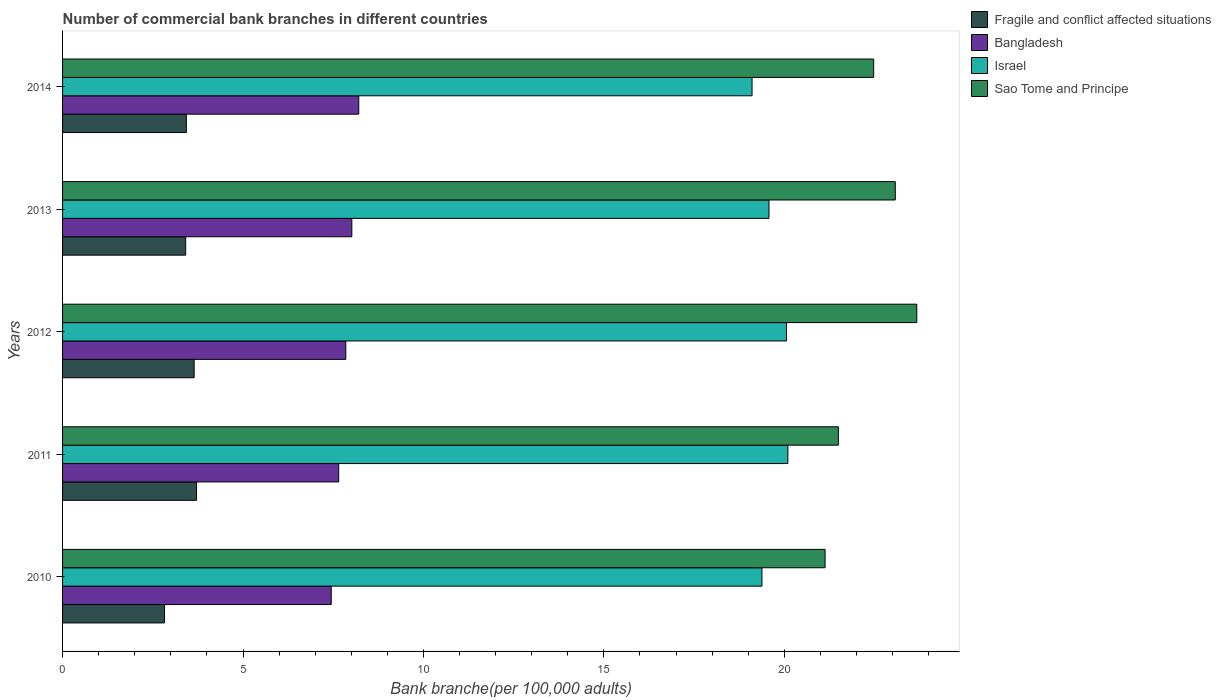How many different coloured bars are there?
Your answer should be very brief. 4. Are the number of bars per tick equal to the number of legend labels?
Make the answer very short. Yes. How many bars are there on the 3rd tick from the top?
Keep it short and to the point. 4. How many bars are there on the 2nd tick from the bottom?
Provide a short and direct response. 4. In how many cases, is the number of bars for a given year not equal to the number of legend labels?
Make the answer very short. 0. What is the number of commercial bank branches in Sao Tome and Principe in 2014?
Give a very brief answer. 22.48. Across all years, what is the maximum number of commercial bank branches in Bangladesh?
Ensure brevity in your answer.  8.21. Across all years, what is the minimum number of commercial bank branches in Fragile and conflict affected situations?
Provide a succinct answer. 2.83. In which year was the number of commercial bank branches in Israel maximum?
Ensure brevity in your answer.  2011. In which year was the number of commercial bank branches in Israel minimum?
Offer a very short reply. 2014. What is the total number of commercial bank branches in Fragile and conflict affected situations in the graph?
Give a very brief answer. 17.03. What is the difference between the number of commercial bank branches in Bangladesh in 2010 and that in 2011?
Your answer should be compact. -0.21. What is the difference between the number of commercial bank branches in Israel in 2011 and the number of commercial bank branches in Bangladesh in 2013?
Provide a short and direct response. 12.08. What is the average number of commercial bank branches in Israel per year?
Your answer should be compact. 19.64. In the year 2013, what is the difference between the number of commercial bank branches in Fragile and conflict affected situations and number of commercial bank branches in Bangladesh?
Give a very brief answer. -4.6. In how many years, is the number of commercial bank branches in Bangladesh greater than 14 ?
Give a very brief answer. 0. What is the ratio of the number of commercial bank branches in Israel in 2011 to that in 2013?
Ensure brevity in your answer.  1.03. Is the number of commercial bank branches in Israel in 2013 less than that in 2014?
Make the answer very short. No. Is the difference between the number of commercial bank branches in Fragile and conflict affected situations in 2010 and 2013 greater than the difference between the number of commercial bank branches in Bangladesh in 2010 and 2013?
Give a very brief answer. No. What is the difference between the highest and the second highest number of commercial bank branches in Israel?
Provide a short and direct response. 0.04. What is the difference between the highest and the lowest number of commercial bank branches in Sao Tome and Principe?
Provide a short and direct response. 2.54. In how many years, is the number of commercial bank branches in Bangladesh greater than the average number of commercial bank branches in Bangladesh taken over all years?
Offer a terse response. 3. What does the 2nd bar from the top in 2013 represents?
Offer a very short reply. Israel. What does the 4th bar from the bottom in 2012 represents?
Your response must be concise. Sao Tome and Principe. Are the values on the major ticks of X-axis written in scientific E-notation?
Ensure brevity in your answer.  No. Where does the legend appear in the graph?
Give a very brief answer. Top right. How many legend labels are there?
Your answer should be very brief. 4. How are the legend labels stacked?
Keep it short and to the point. Vertical. What is the title of the graph?
Keep it short and to the point. Number of commercial bank branches in different countries. What is the label or title of the X-axis?
Ensure brevity in your answer.  Bank branche(per 100,0 adults). What is the Bank branche(per 100,000 adults) in Fragile and conflict affected situations in 2010?
Keep it short and to the point. 2.83. What is the Bank branche(per 100,000 adults) in Bangladesh in 2010?
Keep it short and to the point. 7.44. What is the Bank branche(per 100,000 adults) in Israel in 2010?
Ensure brevity in your answer.  19.38. What is the Bank branche(per 100,000 adults) of Sao Tome and Principe in 2010?
Your answer should be compact. 21.13. What is the Bank branche(per 100,000 adults) in Fragile and conflict affected situations in 2011?
Your response must be concise. 3.71. What is the Bank branche(per 100,000 adults) of Bangladesh in 2011?
Make the answer very short. 7.65. What is the Bank branche(per 100,000 adults) of Israel in 2011?
Keep it short and to the point. 20.1. What is the Bank branche(per 100,000 adults) in Sao Tome and Principe in 2011?
Make the answer very short. 21.5. What is the Bank branche(per 100,000 adults) in Fragile and conflict affected situations in 2012?
Provide a succinct answer. 3.65. What is the Bank branche(per 100,000 adults) in Bangladesh in 2012?
Your response must be concise. 7.85. What is the Bank branche(per 100,000 adults) of Israel in 2012?
Provide a succinct answer. 20.06. What is the Bank branche(per 100,000 adults) of Sao Tome and Principe in 2012?
Give a very brief answer. 23.67. What is the Bank branche(per 100,000 adults) of Fragile and conflict affected situations in 2013?
Offer a terse response. 3.41. What is the Bank branche(per 100,000 adults) in Bangladesh in 2013?
Your response must be concise. 8.02. What is the Bank branche(per 100,000 adults) of Israel in 2013?
Provide a succinct answer. 19.57. What is the Bank branche(per 100,000 adults) in Sao Tome and Principe in 2013?
Offer a terse response. 23.07. What is the Bank branche(per 100,000 adults) in Fragile and conflict affected situations in 2014?
Make the answer very short. 3.43. What is the Bank branche(per 100,000 adults) in Bangladesh in 2014?
Ensure brevity in your answer.  8.21. What is the Bank branche(per 100,000 adults) of Israel in 2014?
Offer a terse response. 19.11. What is the Bank branche(per 100,000 adults) in Sao Tome and Principe in 2014?
Your response must be concise. 22.48. Across all years, what is the maximum Bank branche(per 100,000 adults) of Fragile and conflict affected situations?
Keep it short and to the point. 3.71. Across all years, what is the maximum Bank branche(per 100,000 adults) in Bangladesh?
Ensure brevity in your answer.  8.21. Across all years, what is the maximum Bank branche(per 100,000 adults) of Israel?
Your answer should be compact. 20.1. Across all years, what is the maximum Bank branche(per 100,000 adults) in Sao Tome and Principe?
Your answer should be very brief. 23.67. Across all years, what is the minimum Bank branche(per 100,000 adults) in Fragile and conflict affected situations?
Provide a succinct answer. 2.83. Across all years, what is the minimum Bank branche(per 100,000 adults) of Bangladesh?
Your answer should be compact. 7.44. Across all years, what is the minimum Bank branche(per 100,000 adults) of Israel?
Your response must be concise. 19.11. Across all years, what is the minimum Bank branche(per 100,000 adults) of Sao Tome and Principe?
Your answer should be very brief. 21.13. What is the total Bank branche(per 100,000 adults) of Fragile and conflict affected situations in the graph?
Your answer should be very brief. 17.03. What is the total Bank branche(per 100,000 adults) in Bangladesh in the graph?
Provide a short and direct response. 39.17. What is the total Bank branche(per 100,000 adults) in Israel in the graph?
Give a very brief answer. 98.22. What is the total Bank branche(per 100,000 adults) in Sao Tome and Principe in the graph?
Your answer should be compact. 111.84. What is the difference between the Bank branche(per 100,000 adults) of Fragile and conflict affected situations in 2010 and that in 2011?
Provide a succinct answer. -0.89. What is the difference between the Bank branche(per 100,000 adults) in Bangladesh in 2010 and that in 2011?
Make the answer very short. -0.21. What is the difference between the Bank branche(per 100,000 adults) in Israel in 2010 and that in 2011?
Offer a terse response. -0.72. What is the difference between the Bank branche(per 100,000 adults) in Sao Tome and Principe in 2010 and that in 2011?
Your answer should be very brief. -0.37. What is the difference between the Bank branche(per 100,000 adults) of Fragile and conflict affected situations in 2010 and that in 2012?
Ensure brevity in your answer.  -0.82. What is the difference between the Bank branche(per 100,000 adults) in Bangladesh in 2010 and that in 2012?
Provide a short and direct response. -0.4. What is the difference between the Bank branche(per 100,000 adults) of Israel in 2010 and that in 2012?
Your answer should be compact. -0.68. What is the difference between the Bank branche(per 100,000 adults) of Sao Tome and Principe in 2010 and that in 2012?
Your answer should be compact. -2.54. What is the difference between the Bank branche(per 100,000 adults) in Fragile and conflict affected situations in 2010 and that in 2013?
Your response must be concise. -0.59. What is the difference between the Bank branche(per 100,000 adults) of Bangladesh in 2010 and that in 2013?
Provide a succinct answer. -0.57. What is the difference between the Bank branche(per 100,000 adults) of Israel in 2010 and that in 2013?
Provide a short and direct response. -0.19. What is the difference between the Bank branche(per 100,000 adults) in Sao Tome and Principe in 2010 and that in 2013?
Offer a terse response. -1.94. What is the difference between the Bank branche(per 100,000 adults) of Fragile and conflict affected situations in 2010 and that in 2014?
Keep it short and to the point. -0.61. What is the difference between the Bank branche(per 100,000 adults) of Bangladesh in 2010 and that in 2014?
Offer a terse response. -0.76. What is the difference between the Bank branche(per 100,000 adults) of Israel in 2010 and that in 2014?
Your answer should be very brief. 0.27. What is the difference between the Bank branche(per 100,000 adults) of Sao Tome and Principe in 2010 and that in 2014?
Your answer should be very brief. -1.35. What is the difference between the Bank branche(per 100,000 adults) of Fragile and conflict affected situations in 2011 and that in 2012?
Offer a very short reply. 0.07. What is the difference between the Bank branche(per 100,000 adults) in Bangladesh in 2011 and that in 2012?
Ensure brevity in your answer.  -0.2. What is the difference between the Bank branche(per 100,000 adults) in Israel in 2011 and that in 2012?
Offer a terse response. 0.04. What is the difference between the Bank branche(per 100,000 adults) of Sao Tome and Principe in 2011 and that in 2012?
Ensure brevity in your answer.  -2.17. What is the difference between the Bank branche(per 100,000 adults) of Fragile and conflict affected situations in 2011 and that in 2013?
Give a very brief answer. 0.3. What is the difference between the Bank branche(per 100,000 adults) of Bangladesh in 2011 and that in 2013?
Your answer should be very brief. -0.36. What is the difference between the Bank branche(per 100,000 adults) of Israel in 2011 and that in 2013?
Offer a very short reply. 0.52. What is the difference between the Bank branche(per 100,000 adults) of Sao Tome and Principe in 2011 and that in 2013?
Your answer should be very brief. -1.58. What is the difference between the Bank branche(per 100,000 adults) in Fragile and conflict affected situations in 2011 and that in 2014?
Make the answer very short. 0.28. What is the difference between the Bank branche(per 100,000 adults) in Bangladesh in 2011 and that in 2014?
Give a very brief answer. -0.56. What is the difference between the Bank branche(per 100,000 adults) of Israel in 2011 and that in 2014?
Ensure brevity in your answer.  0.99. What is the difference between the Bank branche(per 100,000 adults) in Sao Tome and Principe in 2011 and that in 2014?
Offer a very short reply. -0.98. What is the difference between the Bank branche(per 100,000 adults) in Fragile and conflict affected situations in 2012 and that in 2013?
Make the answer very short. 0.23. What is the difference between the Bank branche(per 100,000 adults) of Bangladesh in 2012 and that in 2013?
Provide a succinct answer. -0.17. What is the difference between the Bank branche(per 100,000 adults) in Israel in 2012 and that in 2013?
Provide a succinct answer. 0.49. What is the difference between the Bank branche(per 100,000 adults) of Sao Tome and Principe in 2012 and that in 2013?
Your response must be concise. 0.6. What is the difference between the Bank branche(per 100,000 adults) of Fragile and conflict affected situations in 2012 and that in 2014?
Your answer should be very brief. 0.22. What is the difference between the Bank branche(per 100,000 adults) in Bangladesh in 2012 and that in 2014?
Offer a terse response. -0.36. What is the difference between the Bank branche(per 100,000 adults) of Israel in 2012 and that in 2014?
Ensure brevity in your answer.  0.95. What is the difference between the Bank branche(per 100,000 adults) of Sao Tome and Principe in 2012 and that in 2014?
Ensure brevity in your answer.  1.2. What is the difference between the Bank branche(per 100,000 adults) in Fragile and conflict affected situations in 2013 and that in 2014?
Keep it short and to the point. -0.02. What is the difference between the Bank branche(per 100,000 adults) of Bangladesh in 2013 and that in 2014?
Your answer should be compact. -0.19. What is the difference between the Bank branche(per 100,000 adults) of Israel in 2013 and that in 2014?
Offer a very short reply. 0.47. What is the difference between the Bank branche(per 100,000 adults) of Sao Tome and Principe in 2013 and that in 2014?
Make the answer very short. 0.6. What is the difference between the Bank branche(per 100,000 adults) of Fragile and conflict affected situations in 2010 and the Bank branche(per 100,000 adults) of Bangladesh in 2011?
Keep it short and to the point. -4.83. What is the difference between the Bank branche(per 100,000 adults) of Fragile and conflict affected situations in 2010 and the Bank branche(per 100,000 adults) of Israel in 2011?
Keep it short and to the point. -17.27. What is the difference between the Bank branche(per 100,000 adults) in Fragile and conflict affected situations in 2010 and the Bank branche(per 100,000 adults) in Sao Tome and Principe in 2011?
Provide a short and direct response. -18.67. What is the difference between the Bank branche(per 100,000 adults) of Bangladesh in 2010 and the Bank branche(per 100,000 adults) of Israel in 2011?
Ensure brevity in your answer.  -12.65. What is the difference between the Bank branche(per 100,000 adults) of Bangladesh in 2010 and the Bank branche(per 100,000 adults) of Sao Tome and Principe in 2011?
Make the answer very short. -14.05. What is the difference between the Bank branche(per 100,000 adults) in Israel in 2010 and the Bank branche(per 100,000 adults) in Sao Tome and Principe in 2011?
Provide a succinct answer. -2.12. What is the difference between the Bank branche(per 100,000 adults) in Fragile and conflict affected situations in 2010 and the Bank branche(per 100,000 adults) in Bangladesh in 2012?
Keep it short and to the point. -5.02. What is the difference between the Bank branche(per 100,000 adults) in Fragile and conflict affected situations in 2010 and the Bank branche(per 100,000 adults) in Israel in 2012?
Offer a terse response. -17.23. What is the difference between the Bank branche(per 100,000 adults) in Fragile and conflict affected situations in 2010 and the Bank branche(per 100,000 adults) in Sao Tome and Principe in 2012?
Your answer should be compact. -20.84. What is the difference between the Bank branche(per 100,000 adults) of Bangladesh in 2010 and the Bank branche(per 100,000 adults) of Israel in 2012?
Your answer should be compact. -12.62. What is the difference between the Bank branche(per 100,000 adults) of Bangladesh in 2010 and the Bank branche(per 100,000 adults) of Sao Tome and Principe in 2012?
Offer a terse response. -16.23. What is the difference between the Bank branche(per 100,000 adults) of Israel in 2010 and the Bank branche(per 100,000 adults) of Sao Tome and Principe in 2012?
Provide a short and direct response. -4.29. What is the difference between the Bank branche(per 100,000 adults) in Fragile and conflict affected situations in 2010 and the Bank branche(per 100,000 adults) in Bangladesh in 2013?
Offer a very short reply. -5.19. What is the difference between the Bank branche(per 100,000 adults) of Fragile and conflict affected situations in 2010 and the Bank branche(per 100,000 adults) of Israel in 2013?
Your answer should be very brief. -16.75. What is the difference between the Bank branche(per 100,000 adults) in Fragile and conflict affected situations in 2010 and the Bank branche(per 100,000 adults) in Sao Tome and Principe in 2013?
Offer a very short reply. -20.25. What is the difference between the Bank branche(per 100,000 adults) in Bangladesh in 2010 and the Bank branche(per 100,000 adults) in Israel in 2013?
Provide a short and direct response. -12.13. What is the difference between the Bank branche(per 100,000 adults) of Bangladesh in 2010 and the Bank branche(per 100,000 adults) of Sao Tome and Principe in 2013?
Give a very brief answer. -15.63. What is the difference between the Bank branche(per 100,000 adults) of Israel in 2010 and the Bank branche(per 100,000 adults) of Sao Tome and Principe in 2013?
Provide a short and direct response. -3.69. What is the difference between the Bank branche(per 100,000 adults) in Fragile and conflict affected situations in 2010 and the Bank branche(per 100,000 adults) in Bangladesh in 2014?
Make the answer very short. -5.38. What is the difference between the Bank branche(per 100,000 adults) of Fragile and conflict affected situations in 2010 and the Bank branche(per 100,000 adults) of Israel in 2014?
Offer a very short reply. -16.28. What is the difference between the Bank branche(per 100,000 adults) of Fragile and conflict affected situations in 2010 and the Bank branche(per 100,000 adults) of Sao Tome and Principe in 2014?
Offer a very short reply. -19.65. What is the difference between the Bank branche(per 100,000 adults) in Bangladesh in 2010 and the Bank branche(per 100,000 adults) in Israel in 2014?
Your response must be concise. -11.66. What is the difference between the Bank branche(per 100,000 adults) of Bangladesh in 2010 and the Bank branche(per 100,000 adults) of Sao Tome and Principe in 2014?
Your response must be concise. -15.03. What is the difference between the Bank branche(per 100,000 adults) in Israel in 2010 and the Bank branche(per 100,000 adults) in Sao Tome and Principe in 2014?
Give a very brief answer. -3.1. What is the difference between the Bank branche(per 100,000 adults) of Fragile and conflict affected situations in 2011 and the Bank branche(per 100,000 adults) of Bangladesh in 2012?
Your response must be concise. -4.14. What is the difference between the Bank branche(per 100,000 adults) of Fragile and conflict affected situations in 2011 and the Bank branche(per 100,000 adults) of Israel in 2012?
Ensure brevity in your answer.  -16.35. What is the difference between the Bank branche(per 100,000 adults) in Fragile and conflict affected situations in 2011 and the Bank branche(per 100,000 adults) in Sao Tome and Principe in 2012?
Make the answer very short. -19.96. What is the difference between the Bank branche(per 100,000 adults) of Bangladesh in 2011 and the Bank branche(per 100,000 adults) of Israel in 2012?
Ensure brevity in your answer.  -12.41. What is the difference between the Bank branche(per 100,000 adults) of Bangladesh in 2011 and the Bank branche(per 100,000 adults) of Sao Tome and Principe in 2012?
Provide a short and direct response. -16.02. What is the difference between the Bank branche(per 100,000 adults) in Israel in 2011 and the Bank branche(per 100,000 adults) in Sao Tome and Principe in 2012?
Your answer should be compact. -3.57. What is the difference between the Bank branche(per 100,000 adults) in Fragile and conflict affected situations in 2011 and the Bank branche(per 100,000 adults) in Bangladesh in 2013?
Your answer should be very brief. -4.3. What is the difference between the Bank branche(per 100,000 adults) in Fragile and conflict affected situations in 2011 and the Bank branche(per 100,000 adults) in Israel in 2013?
Give a very brief answer. -15.86. What is the difference between the Bank branche(per 100,000 adults) in Fragile and conflict affected situations in 2011 and the Bank branche(per 100,000 adults) in Sao Tome and Principe in 2013?
Your answer should be very brief. -19.36. What is the difference between the Bank branche(per 100,000 adults) in Bangladesh in 2011 and the Bank branche(per 100,000 adults) in Israel in 2013?
Give a very brief answer. -11.92. What is the difference between the Bank branche(per 100,000 adults) of Bangladesh in 2011 and the Bank branche(per 100,000 adults) of Sao Tome and Principe in 2013?
Ensure brevity in your answer.  -15.42. What is the difference between the Bank branche(per 100,000 adults) in Israel in 2011 and the Bank branche(per 100,000 adults) in Sao Tome and Principe in 2013?
Provide a succinct answer. -2.98. What is the difference between the Bank branche(per 100,000 adults) of Fragile and conflict affected situations in 2011 and the Bank branche(per 100,000 adults) of Bangladesh in 2014?
Give a very brief answer. -4.49. What is the difference between the Bank branche(per 100,000 adults) in Fragile and conflict affected situations in 2011 and the Bank branche(per 100,000 adults) in Israel in 2014?
Your answer should be compact. -15.39. What is the difference between the Bank branche(per 100,000 adults) of Fragile and conflict affected situations in 2011 and the Bank branche(per 100,000 adults) of Sao Tome and Principe in 2014?
Provide a succinct answer. -18.76. What is the difference between the Bank branche(per 100,000 adults) in Bangladesh in 2011 and the Bank branche(per 100,000 adults) in Israel in 2014?
Your response must be concise. -11.45. What is the difference between the Bank branche(per 100,000 adults) of Bangladesh in 2011 and the Bank branche(per 100,000 adults) of Sao Tome and Principe in 2014?
Your response must be concise. -14.82. What is the difference between the Bank branche(per 100,000 adults) of Israel in 2011 and the Bank branche(per 100,000 adults) of Sao Tome and Principe in 2014?
Make the answer very short. -2.38. What is the difference between the Bank branche(per 100,000 adults) of Fragile and conflict affected situations in 2012 and the Bank branche(per 100,000 adults) of Bangladesh in 2013?
Ensure brevity in your answer.  -4.37. What is the difference between the Bank branche(per 100,000 adults) of Fragile and conflict affected situations in 2012 and the Bank branche(per 100,000 adults) of Israel in 2013?
Provide a succinct answer. -15.93. What is the difference between the Bank branche(per 100,000 adults) of Fragile and conflict affected situations in 2012 and the Bank branche(per 100,000 adults) of Sao Tome and Principe in 2013?
Give a very brief answer. -19.43. What is the difference between the Bank branche(per 100,000 adults) of Bangladesh in 2012 and the Bank branche(per 100,000 adults) of Israel in 2013?
Your answer should be very brief. -11.73. What is the difference between the Bank branche(per 100,000 adults) in Bangladesh in 2012 and the Bank branche(per 100,000 adults) in Sao Tome and Principe in 2013?
Provide a succinct answer. -15.23. What is the difference between the Bank branche(per 100,000 adults) in Israel in 2012 and the Bank branche(per 100,000 adults) in Sao Tome and Principe in 2013?
Provide a short and direct response. -3.01. What is the difference between the Bank branche(per 100,000 adults) in Fragile and conflict affected situations in 2012 and the Bank branche(per 100,000 adults) in Bangladesh in 2014?
Provide a succinct answer. -4.56. What is the difference between the Bank branche(per 100,000 adults) of Fragile and conflict affected situations in 2012 and the Bank branche(per 100,000 adults) of Israel in 2014?
Ensure brevity in your answer.  -15.46. What is the difference between the Bank branche(per 100,000 adults) of Fragile and conflict affected situations in 2012 and the Bank branche(per 100,000 adults) of Sao Tome and Principe in 2014?
Provide a short and direct response. -18.83. What is the difference between the Bank branche(per 100,000 adults) in Bangladesh in 2012 and the Bank branche(per 100,000 adults) in Israel in 2014?
Your response must be concise. -11.26. What is the difference between the Bank branche(per 100,000 adults) of Bangladesh in 2012 and the Bank branche(per 100,000 adults) of Sao Tome and Principe in 2014?
Your answer should be very brief. -14.63. What is the difference between the Bank branche(per 100,000 adults) of Israel in 2012 and the Bank branche(per 100,000 adults) of Sao Tome and Principe in 2014?
Provide a short and direct response. -2.42. What is the difference between the Bank branche(per 100,000 adults) in Fragile and conflict affected situations in 2013 and the Bank branche(per 100,000 adults) in Bangladesh in 2014?
Provide a succinct answer. -4.8. What is the difference between the Bank branche(per 100,000 adults) of Fragile and conflict affected situations in 2013 and the Bank branche(per 100,000 adults) of Israel in 2014?
Keep it short and to the point. -15.69. What is the difference between the Bank branche(per 100,000 adults) in Fragile and conflict affected situations in 2013 and the Bank branche(per 100,000 adults) in Sao Tome and Principe in 2014?
Ensure brevity in your answer.  -19.06. What is the difference between the Bank branche(per 100,000 adults) in Bangladesh in 2013 and the Bank branche(per 100,000 adults) in Israel in 2014?
Offer a terse response. -11.09. What is the difference between the Bank branche(per 100,000 adults) of Bangladesh in 2013 and the Bank branche(per 100,000 adults) of Sao Tome and Principe in 2014?
Your answer should be very brief. -14.46. What is the difference between the Bank branche(per 100,000 adults) in Israel in 2013 and the Bank branche(per 100,000 adults) in Sao Tome and Principe in 2014?
Your response must be concise. -2.9. What is the average Bank branche(per 100,000 adults) of Fragile and conflict affected situations per year?
Your response must be concise. 3.41. What is the average Bank branche(per 100,000 adults) of Bangladesh per year?
Make the answer very short. 7.83. What is the average Bank branche(per 100,000 adults) of Israel per year?
Offer a terse response. 19.64. What is the average Bank branche(per 100,000 adults) in Sao Tome and Principe per year?
Your response must be concise. 22.37. In the year 2010, what is the difference between the Bank branche(per 100,000 adults) in Fragile and conflict affected situations and Bank branche(per 100,000 adults) in Bangladesh?
Your answer should be compact. -4.62. In the year 2010, what is the difference between the Bank branche(per 100,000 adults) in Fragile and conflict affected situations and Bank branche(per 100,000 adults) in Israel?
Keep it short and to the point. -16.55. In the year 2010, what is the difference between the Bank branche(per 100,000 adults) of Fragile and conflict affected situations and Bank branche(per 100,000 adults) of Sao Tome and Principe?
Offer a very short reply. -18.3. In the year 2010, what is the difference between the Bank branche(per 100,000 adults) of Bangladesh and Bank branche(per 100,000 adults) of Israel?
Offer a very short reply. -11.94. In the year 2010, what is the difference between the Bank branche(per 100,000 adults) in Bangladesh and Bank branche(per 100,000 adults) in Sao Tome and Principe?
Give a very brief answer. -13.68. In the year 2010, what is the difference between the Bank branche(per 100,000 adults) of Israel and Bank branche(per 100,000 adults) of Sao Tome and Principe?
Give a very brief answer. -1.75. In the year 2011, what is the difference between the Bank branche(per 100,000 adults) of Fragile and conflict affected situations and Bank branche(per 100,000 adults) of Bangladesh?
Offer a terse response. -3.94. In the year 2011, what is the difference between the Bank branche(per 100,000 adults) of Fragile and conflict affected situations and Bank branche(per 100,000 adults) of Israel?
Give a very brief answer. -16.38. In the year 2011, what is the difference between the Bank branche(per 100,000 adults) of Fragile and conflict affected situations and Bank branche(per 100,000 adults) of Sao Tome and Principe?
Keep it short and to the point. -17.78. In the year 2011, what is the difference between the Bank branche(per 100,000 adults) in Bangladesh and Bank branche(per 100,000 adults) in Israel?
Provide a short and direct response. -12.45. In the year 2011, what is the difference between the Bank branche(per 100,000 adults) in Bangladesh and Bank branche(per 100,000 adults) in Sao Tome and Principe?
Your answer should be very brief. -13.85. In the year 2011, what is the difference between the Bank branche(per 100,000 adults) in Israel and Bank branche(per 100,000 adults) in Sao Tome and Principe?
Offer a very short reply. -1.4. In the year 2012, what is the difference between the Bank branche(per 100,000 adults) in Fragile and conflict affected situations and Bank branche(per 100,000 adults) in Bangladesh?
Ensure brevity in your answer.  -4.2. In the year 2012, what is the difference between the Bank branche(per 100,000 adults) of Fragile and conflict affected situations and Bank branche(per 100,000 adults) of Israel?
Make the answer very short. -16.41. In the year 2012, what is the difference between the Bank branche(per 100,000 adults) in Fragile and conflict affected situations and Bank branche(per 100,000 adults) in Sao Tome and Principe?
Make the answer very short. -20.02. In the year 2012, what is the difference between the Bank branche(per 100,000 adults) of Bangladesh and Bank branche(per 100,000 adults) of Israel?
Provide a succinct answer. -12.21. In the year 2012, what is the difference between the Bank branche(per 100,000 adults) in Bangladesh and Bank branche(per 100,000 adults) in Sao Tome and Principe?
Provide a short and direct response. -15.82. In the year 2012, what is the difference between the Bank branche(per 100,000 adults) in Israel and Bank branche(per 100,000 adults) in Sao Tome and Principe?
Give a very brief answer. -3.61. In the year 2013, what is the difference between the Bank branche(per 100,000 adults) in Fragile and conflict affected situations and Bank branche(per 100,000 adults) in Bangladesh?
Make the answer very short. -4.6. In the year 2013, what is the difference between the Bank branche(per 100,000 adults) in Fragile and conflict affected situations and Bank branche(per 100,000 adults) in Israel?
Keep it short and to the point. -16.16. In the year 2013, what is the difference between the Bank branche(per 100,000 adults) in Fragile and conflict affected situations and Bank branche(per 100,000 adults) in Sao Tome and Principe?
Make the answer very short. -19.66. In the year 2013, what is the difference between the Bank branche(per 100,000 adults) in Bangladesh and Bank branche(per 100,000 adults) in Israel?
Offer a terse response. -11.56. In the year 2013, what is the difference between the Bank branche(per 100,000 adults) in Bangladesh and Bank branche(per 100,000 adults) in Sao Tome and Principe?
Your answer should be very brief. -15.06. In the year 2013, what is the difference between the Bank branche(per 100,000 adults) in Israel and Bank branche(per 100,000 adults) in Sao Tome and Principe?
Ensure brevity in your answer.  -3.5. In the year 2014, what is the difference between the Bank branche(per 100,000 adults) of Fragile and conflict affected situations and Bank branche(per 100,000 adults) of Bangladesh?
Give a very brief answer. -4.78. In the year 2014, what is the difference between the Bank branche(per 100,000 adults) in Fragile and conflict affected situations and Bank branche(per 100,000 adults) in Israel?
Offer a very short reply. -15.68. In the year 2014, what is the difference between the Bank branche(per 100,000 adults) of Fragile and conflict affected situations and Bank branche(per 100,000 adults) of Sao Tome and Principe?
Provide a short and direct response. -19.04. In the year 2014, what is the difference between the Bank branche(per 100,000 adults) of Bangladesh and Bank branche(per 100,000 adults) of Israel?
Your answer should be very brief. -10.9. In the year 2014, what is the difference between the Bank branche(per 100,000 adults) in Bangladesh and Bank branche(per 100,000 adults) in Sao Tome and Principe?
Provide a short and direct response. -14.27. In the year 2014, what is the difference between the Bank branche(per 100,000 adults) in Israel and Bank branche(per 100,000 adults) in Sao Tome and Principe?
Offer a very short reply. -3.37. What is the ratio of the Bank branche(per 100,000 adults) in Fragile and conflict affected situations in 2010 to that in 2011?
Offer a very short reply. 0.76. What is the ratio of the Bank branche(per 100,000 adults) in Bangladesh in 2010 to that in 2011?
Offer a terse response. 0.97. What is the ratio of the Bank branche(per 100,000 adults) in Sao Tome and Principe in 2010 to that in 2011?
Provide a succinct answer. 0.98. What is the ratio of the Bank branche(per 100,000 adults) in Fragile and conflict affected situations in 2010 to that in 2012?
Keep it short and to the point. 0.77. What is the ratio of the Bank branche(per 100,000 adults) of Bangladesh in 2010 to that in 2012?
Ensure brevity in your answer.  0.95. What is the ratio of the Bank branche(per 100,000 adults) in Israel in 2010 to that in 2012?
Give a very brief answer. 0.97. What is the ratio of the Bank branche(per 100,000 adults) in Sao Tome and Principe in 2010 to that in 2012?
Provide a short and direct response. 0.89. What is the ratio of the Bank branche(per 100,000 adults) in Fragile and conflict affected situations in 2010 to that in 2013?
Your answer should be very brief. 0.83. What is the ratio of the Bank branche(per 100,000 adults) in Bangladesh in 2010 to that in 2013?
Provide a short and direct response. 0.93. What is the ratio of the Bank branche(per 100,000 adults) of Sao Tome and Principe in 2010 to that in 2013?
Offer a very short reply. 0.92. What is the ratio of the Bank branche(per 100,000 adults) of Fragile and conflict affected situations in 2010 to that in 2014?
Keep it short and to the point. 0.82. What is the ratio of the Bank branche(per 100,000 adults) of Bangladesh in 2010 to that in 2014?
Offer a terse response. 0.91. What is the ratio of the Bank branche(per 100,000 adults) in Israel in 2010 to that in 2014?
Your response must be concise. 1.01. What is the ratio of the Bank branche(per 100,000 adults) in Sao Tome and Principe in 2010 to that in 2014?
Your answer should be very brief. 0.94. What is the ratio of the Bank branche(per 100,000 adults) in Fragile and conflict affected situations in 2011 to that in 2012?
Provide a succinct answer. 1.02. What is the ratio of the Bank branche(per 100,000 adults) in Bangladesh in 2011 to that in 2012?
Your answer should be compact. 0.97. What is the ratio of the Bank branche(per 100,000 adults) in Israel in 2011 to that in 2012?
Provide a short and direct response. 1. What is the ratio of the Bank branche(per 100,000 adults) of Sao Tome and Principe in 2011 to that in 2012?
Make the answer very short. 0.91. What is the ratio of the Bank branche(per 100,000 adults) of Fragile and conflict affected situations in 2011 to that in 2013?
Give a very brief answer. 1.09. What is the ratio of the Bank branche(per 100,000 adults) of Bangladesh in 2011 to that in 2013?
Give a very brief answer. 0.95. What is the ratio of the Bank branche(per 100,000 adults) in Israel in 2011 to that in 2013?
Your answer should be very brief. 1.03. What is the ratio of the Bank branche(per 100,000 adults) in Sao Tome and Principe in 2011 to that in 2013?
Make the answer very short. 0.93. What is the ratio of the Bank branche(per 100,000 adults) in Fragile and conflict affected situations in 2011 to that in 2014?
Your answer should be very brief. 1.08. What is the ratio of the Bank branche(per 100,000 adults) in Bangladesh in 2011 to that in 2014?
Your response must be concise. 0.93. What is the ratio of the Bank branche(per 100,000 adults) of Israel in 2011 to that in 2014?
Your answer should be compact. 1.05. What is the ratio of the Bank branche(per 100,000 adults) of Sao Tome and Principe in 2011 to that in 2014?
Offer a terse response. 0.96. What is the ratio of the Bank branche(per 100,000 adults) of Fragile and conflict affected situations in 2012 to that in 2013?
Your answer should be compact. 1.07. What is the ratio of the Bank branche(per 100,000 adults) of Bangladesh in 2012 to that in 2013?
Make the answer very short. 0.98. What is the ratio of the Bank branche(per 100,000 adults) of Israel in 2012 to that in 2013?
Give a very brief answer. 1.02. What is the ratio of the Bank branche(per 100,000 adults) in Sao Tome and Principe in 2012 to that in 2013?
Your response must be concise. 1.03. What is the ratio of the Bank branche(per 100,000 adults) of Fragile and conflict affected situations in 2012 to that in 2014?
Keep it short and to the point. 1.06. What is the ratio of the Bank branche(per 100,000 adults) of Bangladesh in 2012 to that in 2014?
Provide a succinct answer. 0.96. What is the ratio of the Bank branche(per 100,000 adults) of Israel in 2012 to that in 2014?
Provide a short and direct response. 1.05. What is the ratio of the Bank branche(per 100,000 adults) of Sao Tome and Principe in 2012 to that in 2014?
Keep it short and to the point. 1.05. What is the ratio of the Bank branche(per 100,000 adults) in Bangladesh in 2013 to that in 2014?
Provide a short and direct response. 0.98. What is the ratio of the Bank branche(per 100,000 adults) in Israel in 2013 to that in 2014?
Offer a terse response. 1.02. What is the ratio of the Bank branche(per 100,000 adults) in Sao Tome and Principe in 2013 to that in 2014?
Make the answer very short. 1.03. What is the difference between the highest and the second highest Bank branche(per 100,000 adults) in Fragile and conflict affected situations?
Keep it short and to the point. 0.07. What is the difference between the highest and the second highest Bank branche(per 100,000 adults) in Bangladesh?
Give a very brief answer. 0.19. What is the difference between the highest and the second highest Bank branche(per 100,000 adults) in Israel?
Give a very brief answer. 0.04. What is the difference between the highest and the second highest Bank branche(per 100,000 adults) of Sao Tome and Principe?
Keep it short and to the point. 0.6. What is the difference between the highest and the lowest Bank branche(per 100,000 adults) of Fragile and conflict affected situations?
Give a very brief answer. 0.89. What is the difference between the highest and the lowest Bank branche(per 100,000 adults) of Bangladesh?
Offer a very short reply. 0.76. What is the difference between the highest and the lowest Bank branche(per 100,000 adults) in Israel?
Provide a short and direct response. 0.99. What is the difference between the highest and the lowest Bank branche(per 100,000 adults) of Sao Tome and Principe?
Keep it short and to the point. 2.54. 